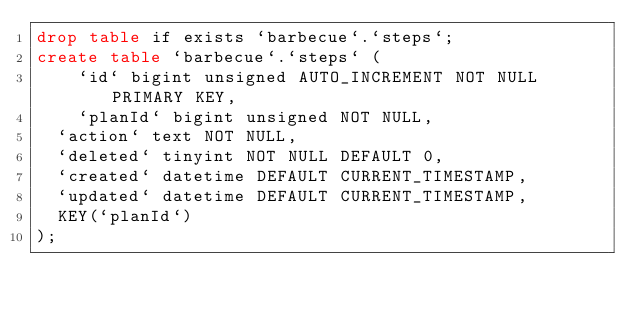Convert code to text. <code><loc_0><loc_0><loc_500><loc_500><_SQL_>drop table if exists `barbecue`.`steps`;
create table `barbecue`.`steps` (
	`id` bigint unsigned AUTO_INCREMENT NOT NULL PRIMARY KEY,
	`planId` bigint unsigned NOT NULL,
  `action` text NOT NULL,
  `deleted` tinyint NOT NULL DEFAULT 0,
  `created` datetime DEFAULT CURRENT_TIMESTAMP,
  `updated` datetime DEFAULT CURRENT_TIMESTAMP,
  KEY(`planId`)
);</code> 